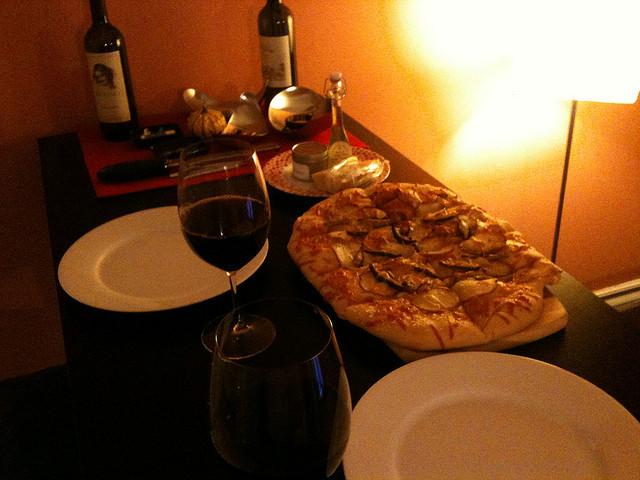What is the pizza sitting on?
Short answer required. Cutting board. What toppings are on the pizza?
Be succinct. Veggies. Is the wine red or white?
Be succinct. Red. How many people can sit at this meal?
Keep it brief. 2. How many place settings are at the table?
Write a very short answer. 2. How many bottles are on the table?
Write a very short answer. 2. 